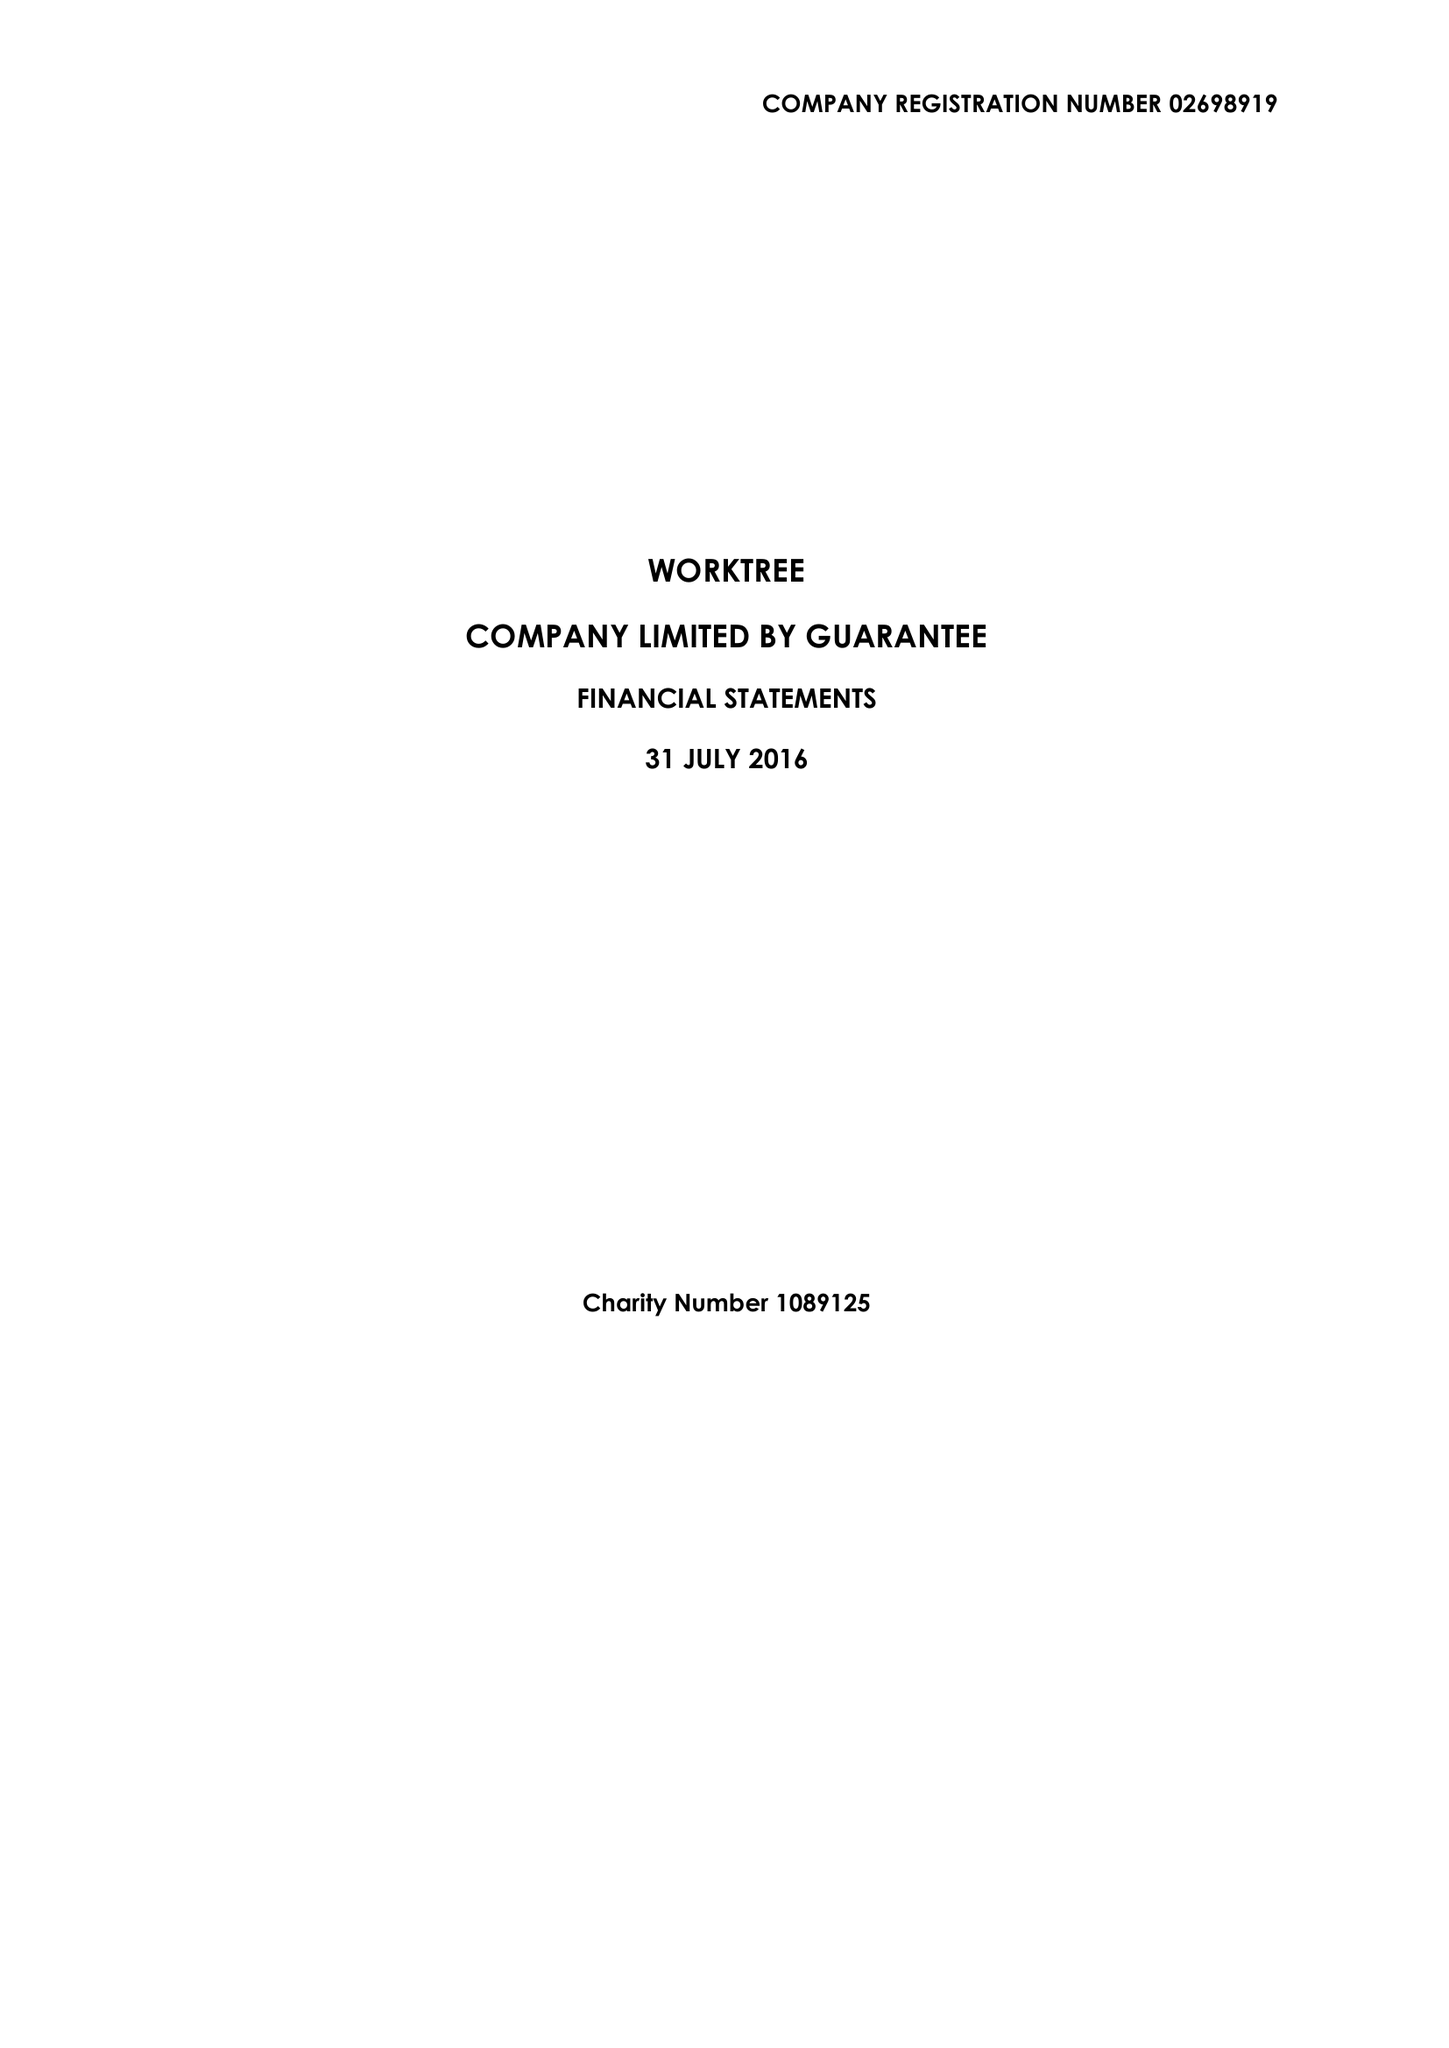What is the value for the report_date?
Answer the question using a single word or phrase. 2016-07-31 